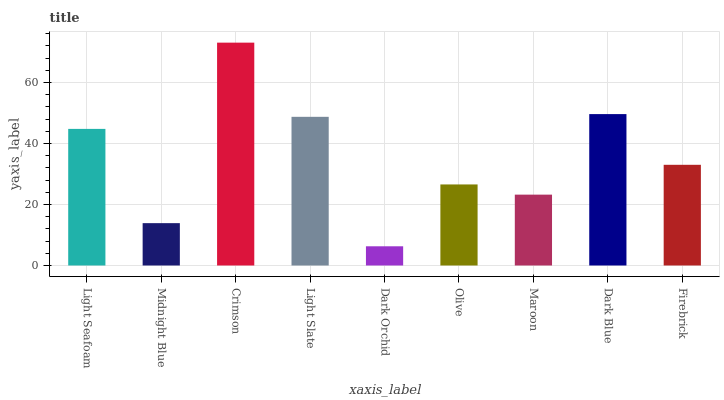Is Dark Orchid the minimum?
Answer yes or no. Yes. Is Crimson the maximum?
Answer yes or no. Yes. Is Midnight Blue the minimum?
Answer yes or no. No. Is Midnight Blue the maximum?
Answer yes or no. No. Is Light Seafoam greater than Midnight Blue?
Answer yes or no. Yes. Is Midnight Blue less than Light Seafoam?
Answer yes or no. Yes. Is Midnight Blue greater than Light Seafoam?
Answer yes or no. No. Is Light Seafoam less than Midnight Blue?
Answer yes or no. No. Is Firebrick the high median?
Answer yes or no. Yes. Is Firebrick the low median?
Answer yes or no. Yes. Is Midnight Blue the high median?
Answer yes or no. No. Is Dark Blue the low median?
Answer yes or no. No. 